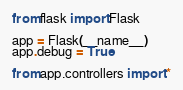Convert code to text. <code><loc_0><loc_0><loc_500><loc_500><_Python_>from flask import Flask

app = Flask(__name__)
app.debug = True

from app.controllers import *</code> 